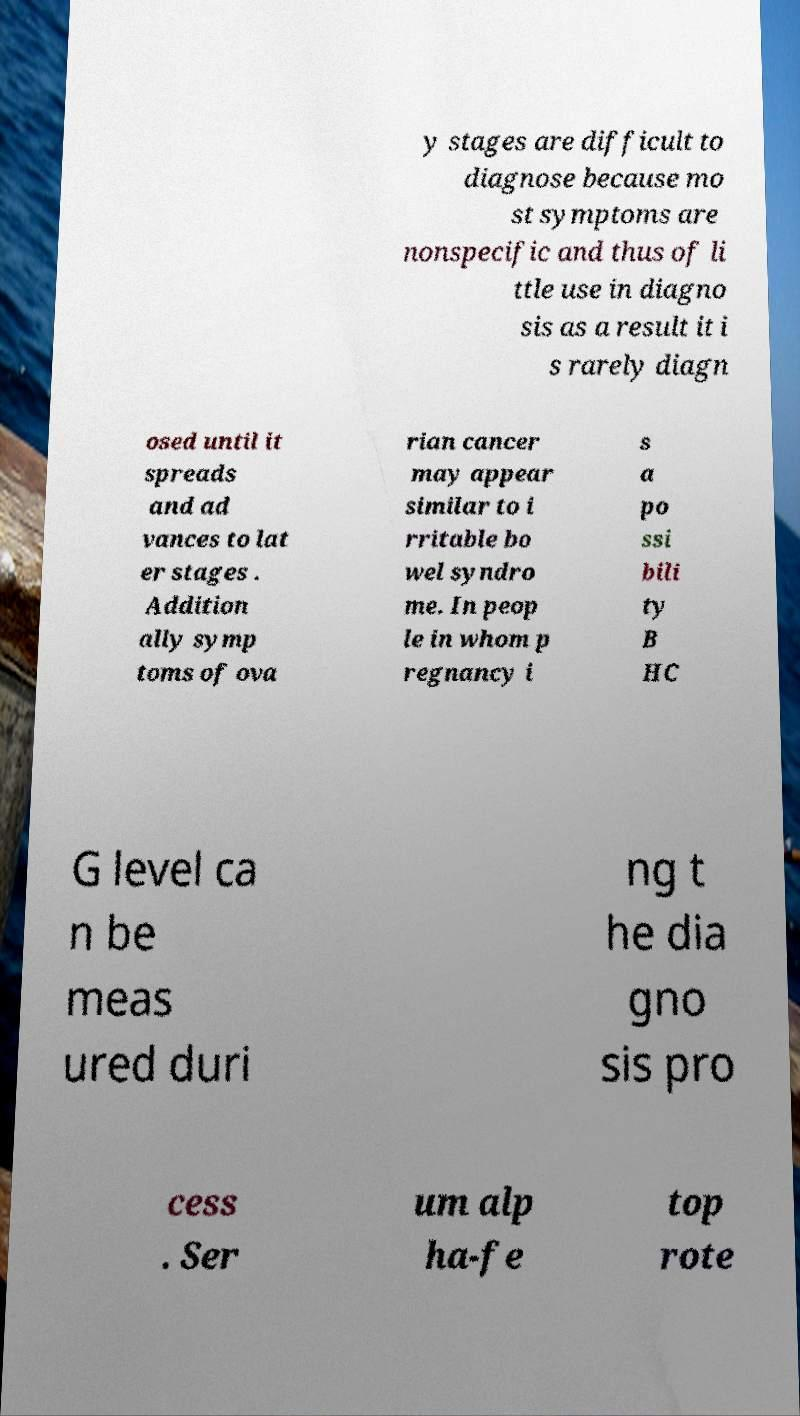I need the written content from this picture converted into text. Can you do that? y stages are difficult to diagnose because mo st symptoms are nonspecific and thus of li ttle use in diagno sis as a result it i s rarely diagn osed until it spreads and ad vances to lat er stages . Addition ally symp toms of ova rian cancer may appear similar to i rritable bo wel syndro me. In peop le in whom p regnancy i s a po ssi bili ty B HC G level ca n be meas ured duri ng t he dia gno sis pro cess . Ser um alp ha-fe top rote 